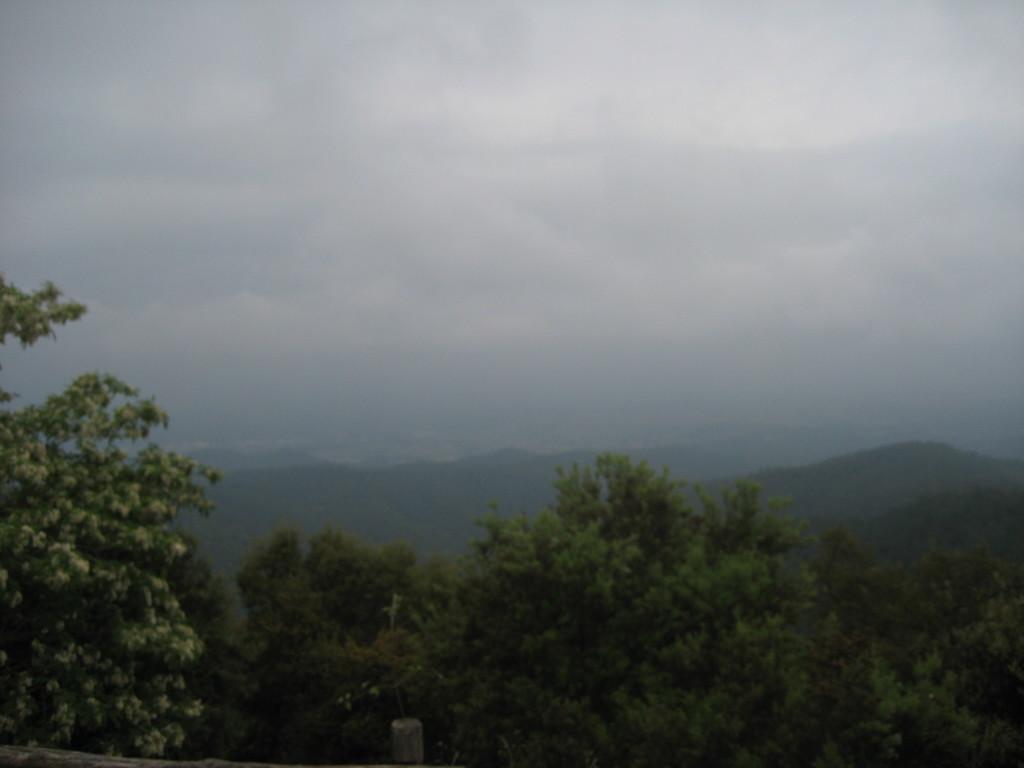Describe this image in one or two sentences. In this image I can see the trees at the bottom of the image. Mountains in the center of the image and sky at the top of the image. 